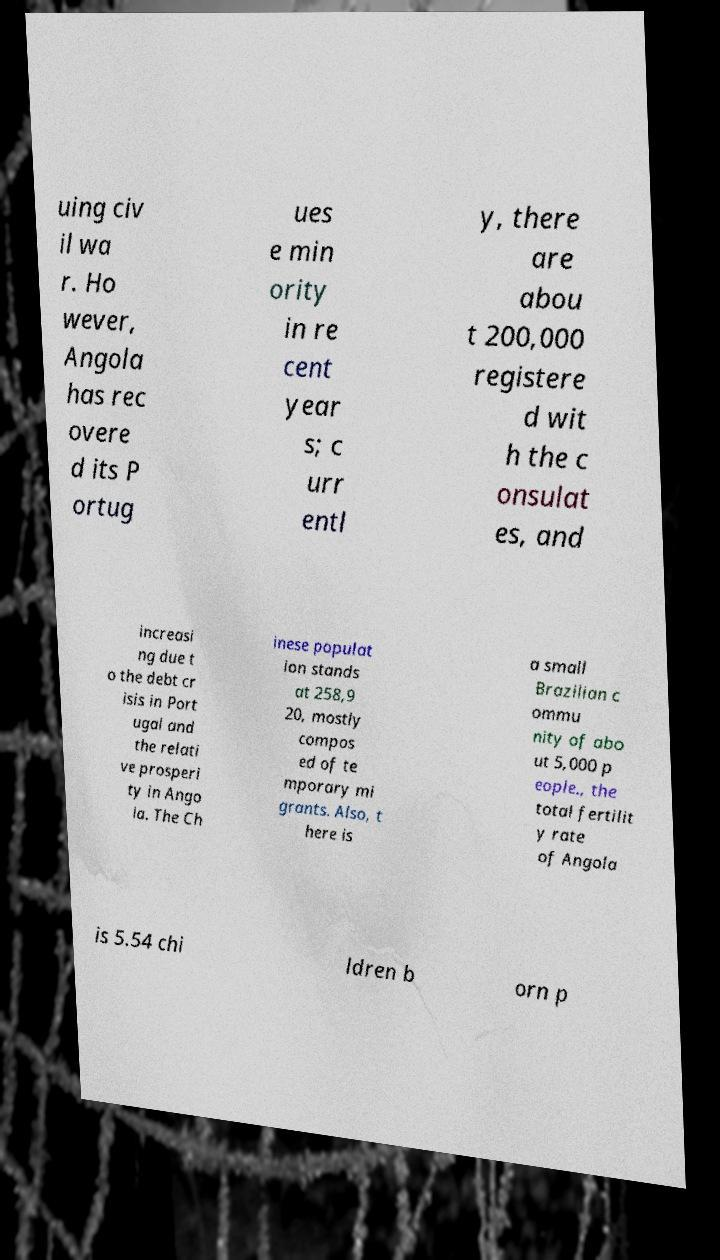Can you read and provide the text displayed in the image?This photo seems to have some interesting text. Can you extract and type it out for me? uing civ il wa r. Ho wever, Angola has rec overe d its P ortug ues e min ority in re cent year s; c urr entl y, there are abou t 200,000 registere d wit h the c onsulat es, and increasi ng due t o the debt cr isis in Port ugal and the relati ve prosperi ty in Ango la. The Ch inese populat ion stands at 258,9 20, mostly compos ed of te mporary mi grants. Also, t here is a small Brazilian c ommu nity of abo ut 5,000 p eople., the total fertilit y rate of Angola is 5.54 chi ldren b orn p 